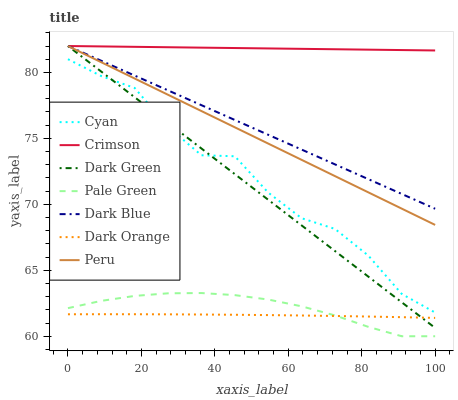Does Dark Orange have the minimum area under the curve?
Answer yes or no. Yes. Does Crimson have the maximum area under the curve?
Answer yes or no. Yes. Does Dark Blue have the minimum area under the curve?
Answer yes or no. No. Does Dark Blue have the maximum area under the curve?
Answer yes or no. No. Is Crimson the smoothest?
Answer yes or no. Yes. Is Cyan the roughest?
Answer yes or no. Yes. Is Dark Blue the smoothest?
Answer yes or no. No. Is Dark Blue the roughest?
Answer yes or no. No. Does Pale Green have the lowest value?
Answer yes or no. Yes. Does Dark Blue have the lowest value?
Answer yes or no. No. Does Dark Green have the highest value?
Answer yes or no. Yes. Does Pale Green have the highest value?
Answer yes or no. No. Is Cyan less than Dark Blue?
Answer yes or no. Yes. Is Peru greater than Dark Orange?
Answer yes or no. Yes. Does Crimson intersect Dark Green?
Answer yes or no. Yes. Is Crimson less than Dark Green?
Answer yes or no. No. Is Crimson greater than Dark Green?
Answer yes or no. No. Does Cyan intersect Dark Blue?
Answer yes or no. No. 